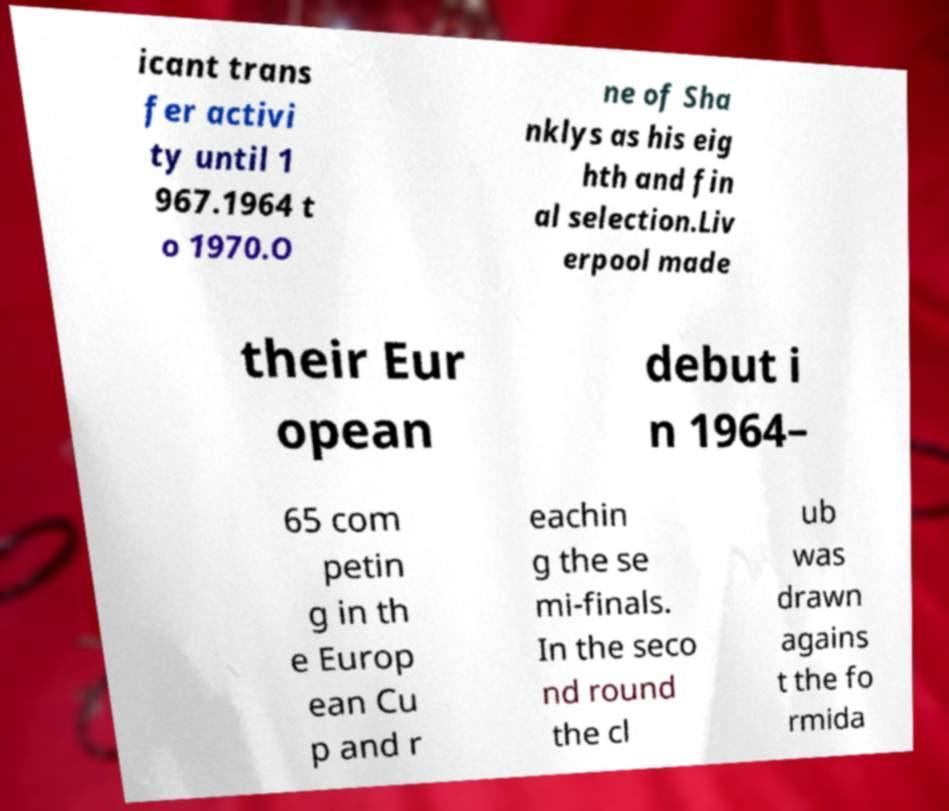For documentation purposes, I need the text within this image transcribed. Could you provide that? icant trans fer activi ty until 1 967.1964 t o 1970.O ne of Sha nklys as his eig hth and fin al selection.Liv erpool made their Eur opean debut i n 1964– 65 com petin g in th e Europ ean Cu p and r eachin g the se mi-finals. In the seco nd round the cl ub was drawn agains t the fo rmida 